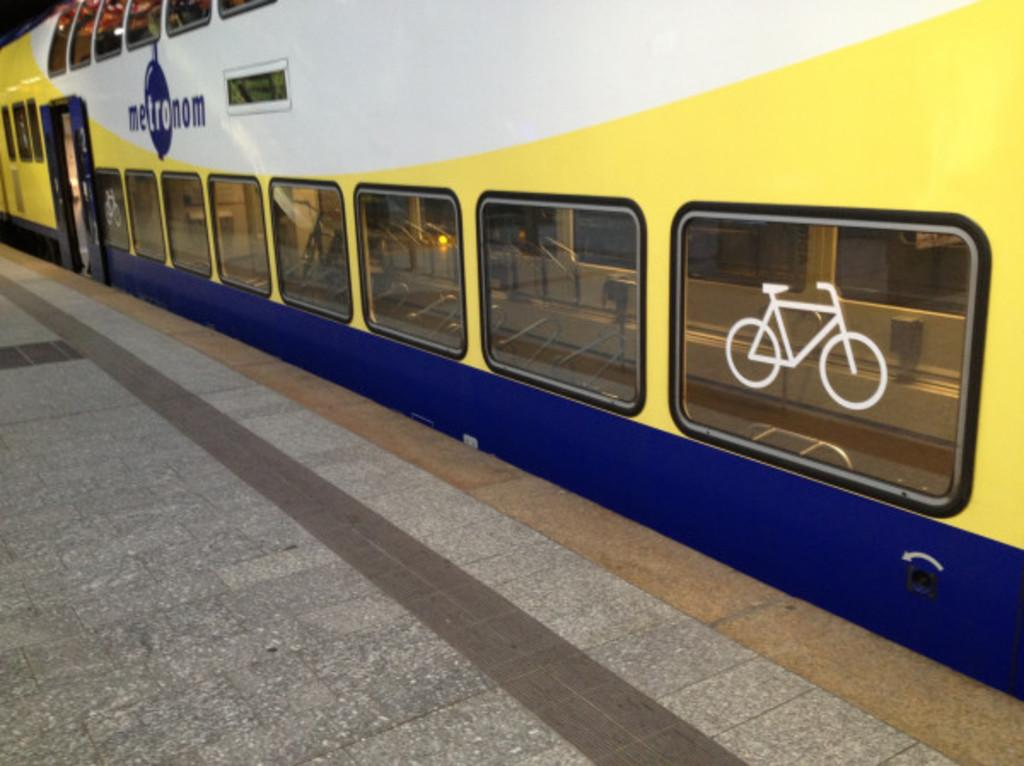What is the main subject of the image? The main subject of the image is a train. Where is the train located in the image? The train is on a railway track. What features can be observed on the train? The train has many windows and a door. What else is present in the image besides the train? There is a railway platform in the image. How many balls can be seen rolling on the railway track in the image? There are no balls present in the image; it features a train on a railway track and a railway platform. What type of snakes are crawling on the train in the image? There are no snakes present in the image; it only features a train, railway track, and railway platform. 